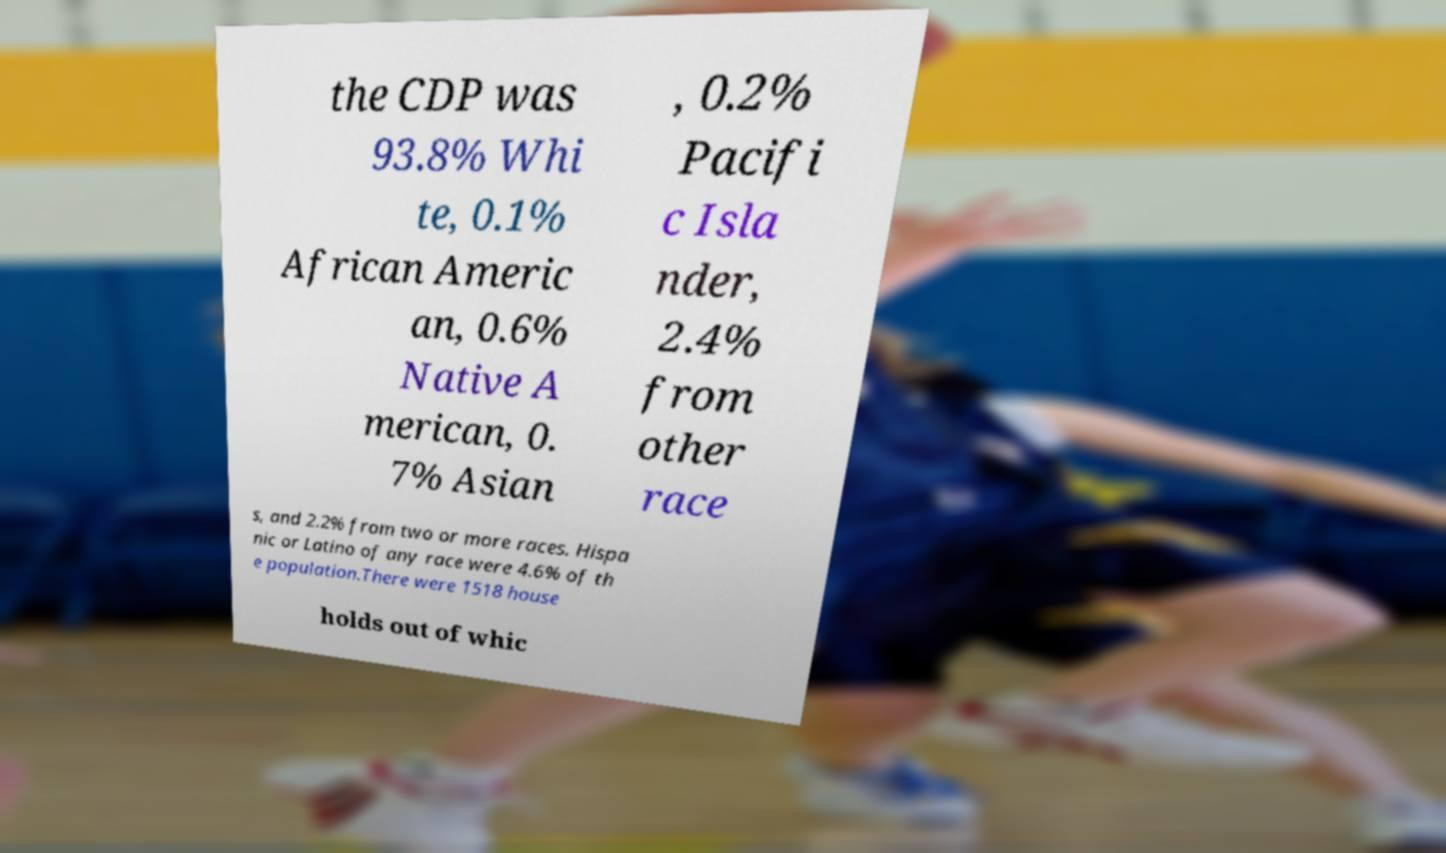Can you accurately transcribe the text from the provided image for me? the CDP was 93.8% Whi te, 0.1% African Americ an, 0.6% Native A merican, 0. 7% Asian , 0.2% Pacifi c Isla nder, 2.4% from other race s, and 2.2% from two or more races. Hispa nic or Latino of any race were 4.6% of th e population.There were 1518 house holds out of whic 